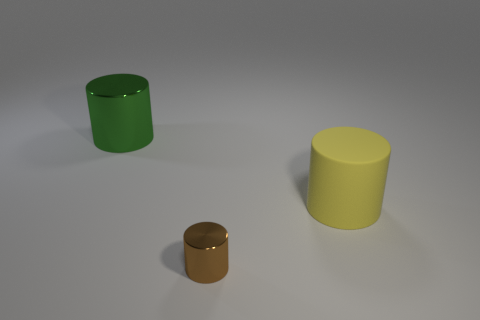Subtract all big yellow cylinders. How many cylinders are left? 2 Add 3 blue metallic spheres. How many objects exist? 6 Subtract all cyan cylinders. Subtract all blue blocks. How many cylinders are left? 3 Subtract 0 purple spheres. How many objects are left? 3 Subtract all large green metal cylinders. Subtract all brown cylinders. How many objects are left? 1 Add 3 large green cylinders. How many large green cylinders are left? 4 Add 3 small brown cylinders. How many small brown cylinders exist? 4 